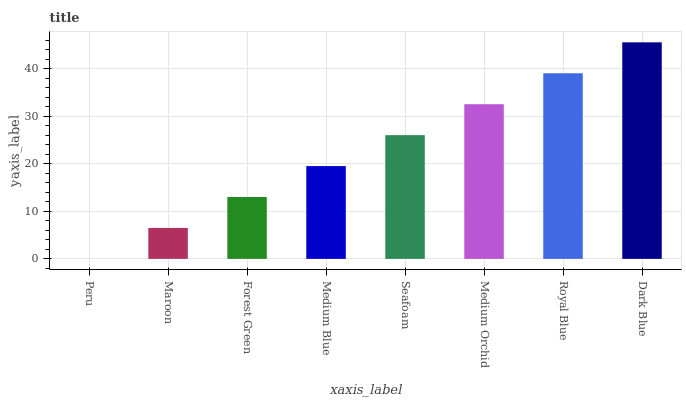Is Peru the minimum?
Answer yes or no. Yes. Is Dark Blue the maximum?
Answer yes or no. Yes. Is Maroon the minimum?
Answer yes or no. No. Is Maroon the maximum?
Answer yes or no. No. Is Maroon greater than Peru?
Answer yes or no. Yes. Is Peru less than Maroon?
Answer yes or no. Yes. Is Peru greater than Maroon?
Answer yes or no. No. Is Maroon less than Peru?
Answer yes or no. No. Is Seafoam the high median?
Answer yes or no. Yes. Is Medium Blue the low median?
Answer yes or no. Yes. Is Forest Green the high median?
Answer yes or no. No. Is Forest Green the low median?
Answer yes or no. No. 